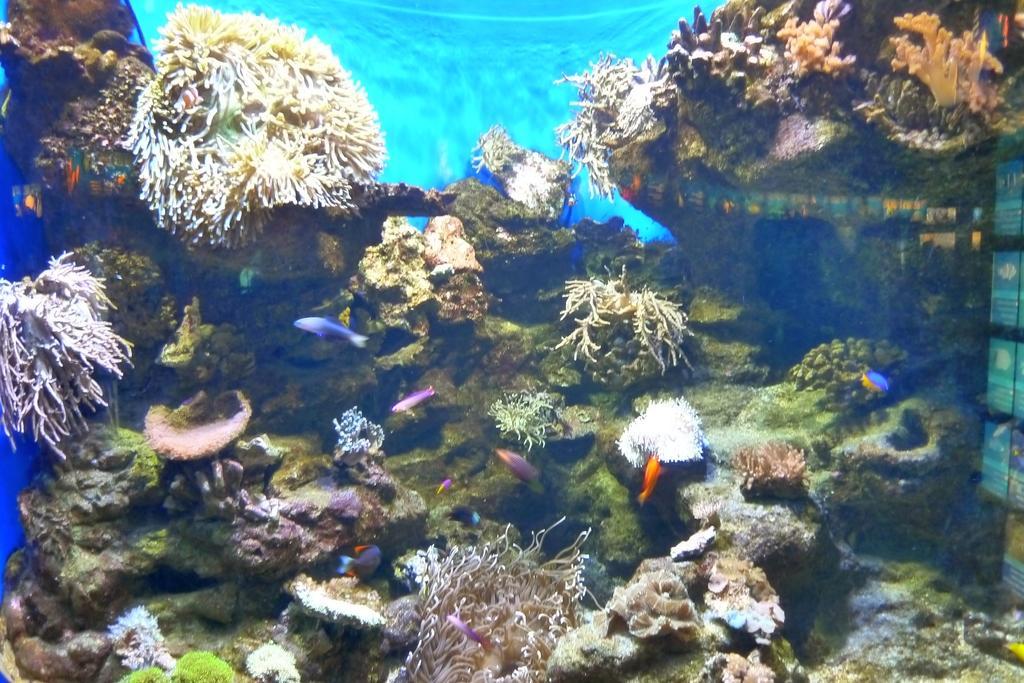How would you summarize this image in a sentence or two? In this image, we can see there are fishes in the water. In the background, there are plants and rocks in the water. And the background is blue in color. 